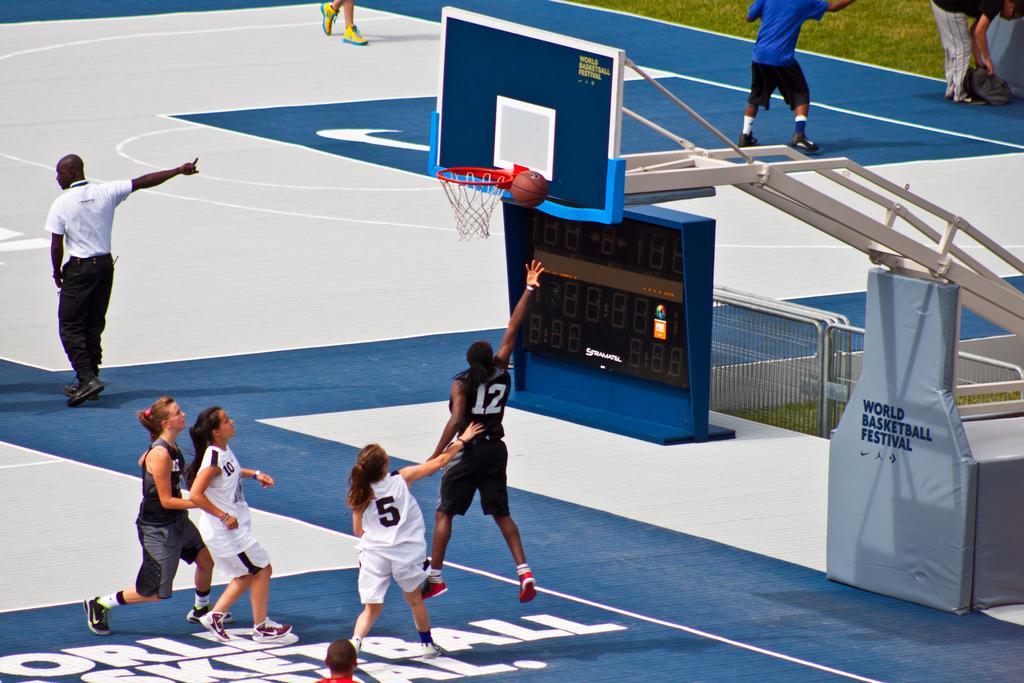Please provide a concise description of this image. In this picture there are people on the left side of the image, they are playing basketball and there are other people at the top side of the image, there are stairs on the right side of the image. 